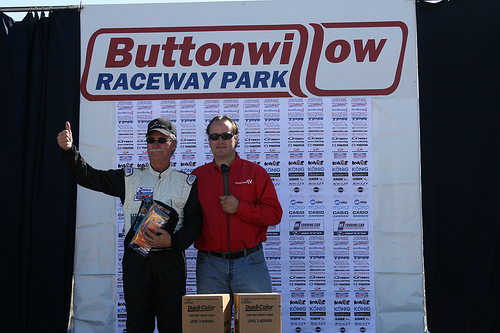<image>
Is the shades on the man? No. The shades is not positioned on the man. They may be near each other, but the shades is not supported by or resting on top of the man. 